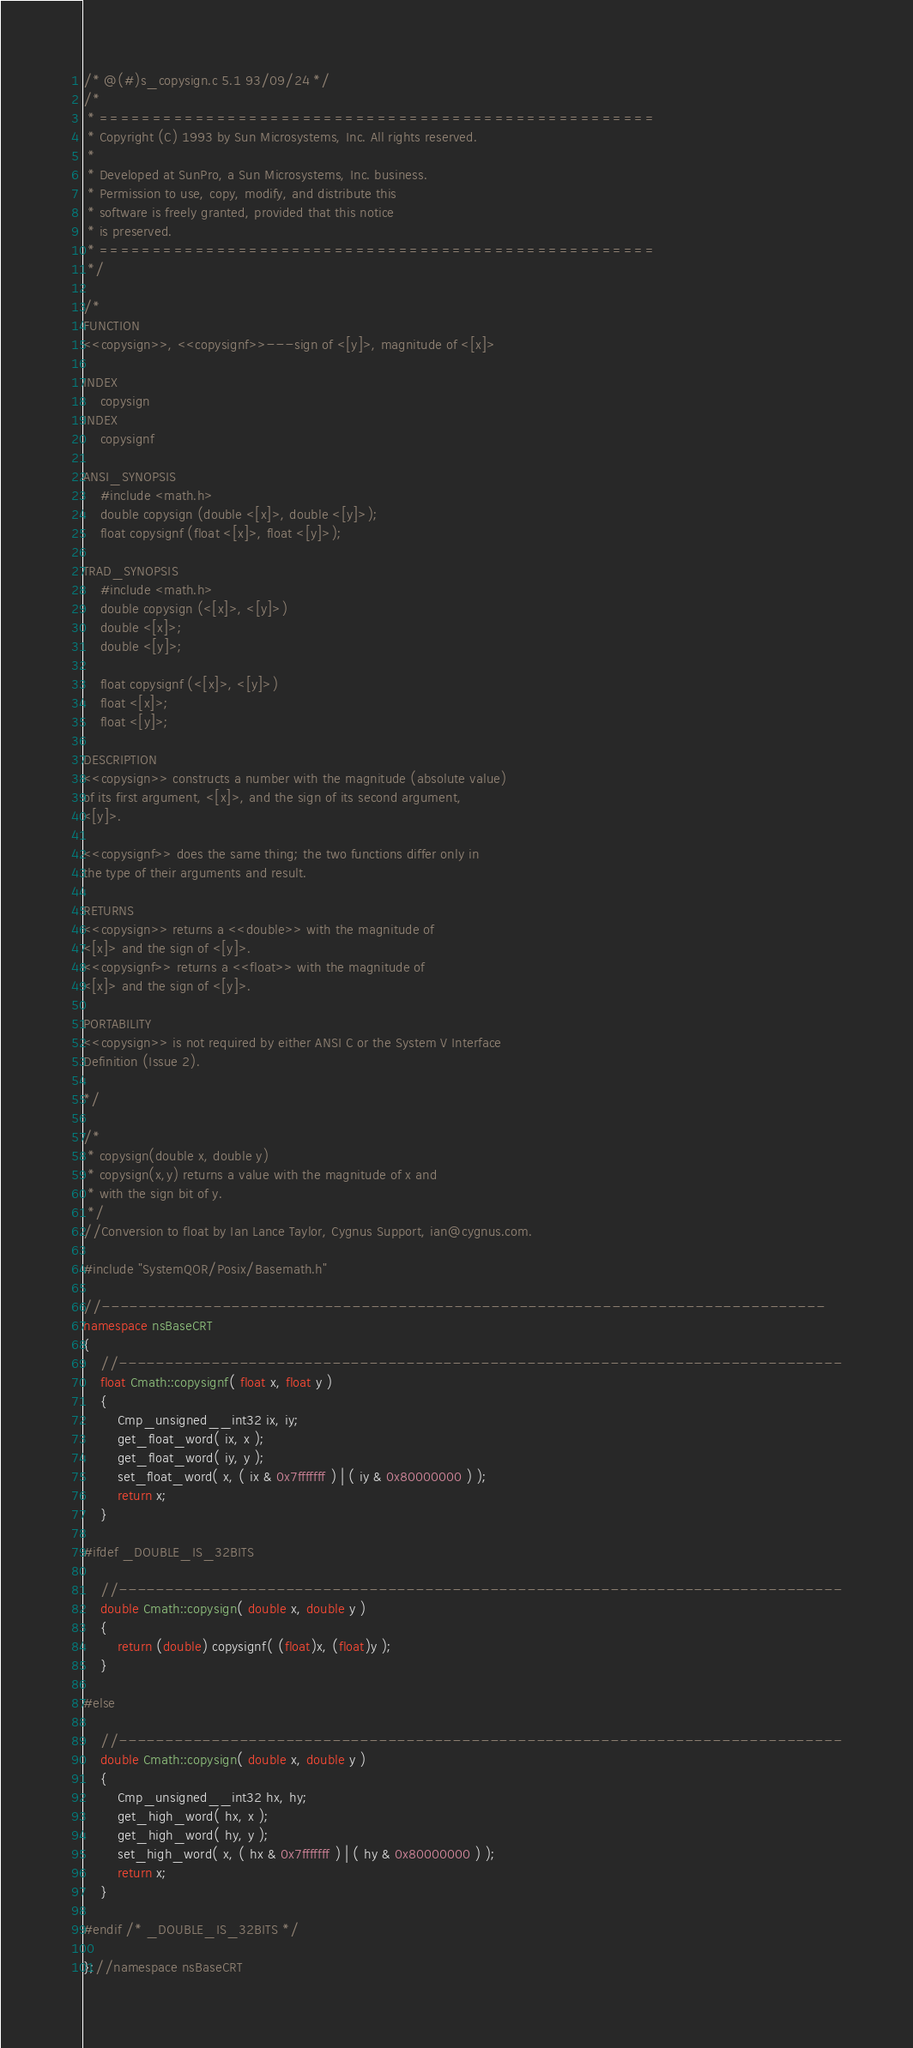<code> <loc_0><loc_0><loc_500><loc_500><_C++_>
/* @(#)s_copysign.c 5.1 93/09/24 */
/*
 * ====================================================
 * Copyright (C) 1993 by Sun Microsystems, Inc. All rights reserved.
 *
 * Developed at SunPro, a Sun Microsystems, Inc. business.
 * Permission to use, copy, modify, and distribute this
 * software is freely granted, provided that this notice 
 * is preserved.
 * ====================================================
 */

/*
FUNCTION
<<copysign>>, <<copysignf>>---sign of <[y]>, magnitude of <[x]>

INDEX
	copysign
INDEX
	copysignf

ANSI_SYNOPSIS
	#include <math.h>
	double copysign (double <[x]>, double <[y]>);
	float copysignf (float <[x]>, float <[y]>);

TRAD_SYNOPSIS
	#include <math.h>
	double copysign (<[x]>, <[y]>)
	double <[x]>;
	double <[y]>;

	float copysignf (<[x]>, <[y]>)
	float <[x]>;
	float <[y]>;

DESCRIPTION
<<copysign>> constructs a number with the magnitude (absolute value)
of its first argument, <[x]>, and the sign of its second argument,
<[y]>.

<<copysignf>> does the same thing; the two functions differ only in
the type of their arguments and result.

RETURNS
<<copysign>> returns a <<double>> with the magnitude of
<[x]> and the sign of <[y]>.
<<copysignf>> returns a <<float>> with the magnitude of
<[x]> and the sign of <[y]>.

PORTABILITY
<<copysign>> is not required by either ANSI C or the System V Interface
Definition (Issue 2).

*/

/*
 * copysign(double x, double y)
 * copysign(x,y) returns a value with the magnitude of x and
 * with the sign bit of y.
 */
//Conversion to float by Ian Lance Taylor, Cygnus Support, ian@cygnus.com.

#include "SystemQOR/Posix/Basemath.h"

//------------------------------------------------------------------------------
namespace nsBaseCRT
{
	//------------------------------------------------------------------------------
	float Cmath::copysignf( float x, float y )
	{
		Cmp_unsigned__int32 ix, iy;
		get_float_word( ix, x );
		get_float_word( iy, y );
		set_float_word( x, ( ix & 0x7fffffff ) | ( iy & 0x80000000 ) );
		return x;
	}

#ifdef _DOUBLE_IS_32BITS

	//------------------------------------------------------------------------------
	double Cmath::copysign( double x, double y )
	{
		return (double) copysignf( (float)x, (float)y );
	}

#else

	//------------------------------------------------------------------------------
	double Cmath::copysign( double x, double y )
	{
		Cmp_unsigned__int32 hx, hy;		
		get_high_word( hx, x );
		get_high_word( hy, y );
		set_high_word( x, ( hx & 0x7fffffff ) | ( hy & 0x80000000 ) );
		return x;
	}

#endif /* _DOUBLE_IS_32BITS */

};//namespace nsBaseCRT

</code> 